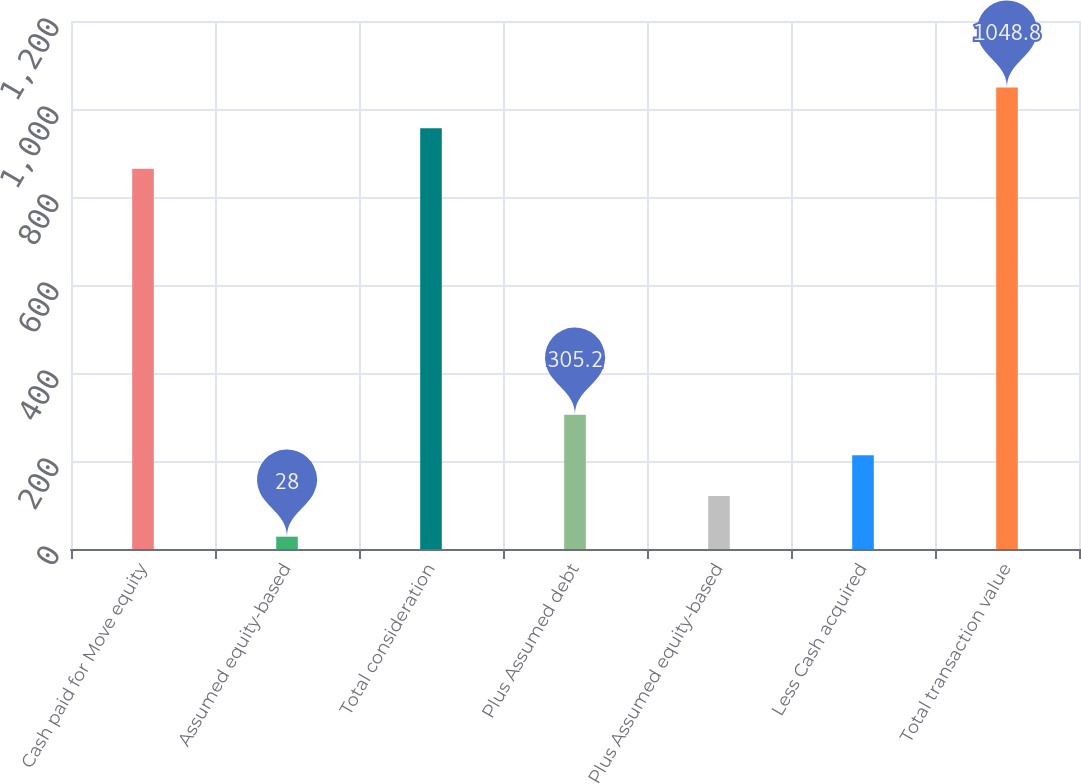Convert chart. <chart><loc_0><loc_0><loc_500><loc_500><bar_chart><fcel>Cash paid for Move equity<fcel>Assumed equity-based<fcel>Total consideration<fcel>Plus Assumed debt<fcel>Plus Assumed equity-based<fcel>Less Cash acquired<fcel>Total transaction value<nl><fcel>864<fcel>28<fcel>956.4<fcel>305.2<fcel>120.4<fcel>212.8<fcel>1048.8<nl></chart> 